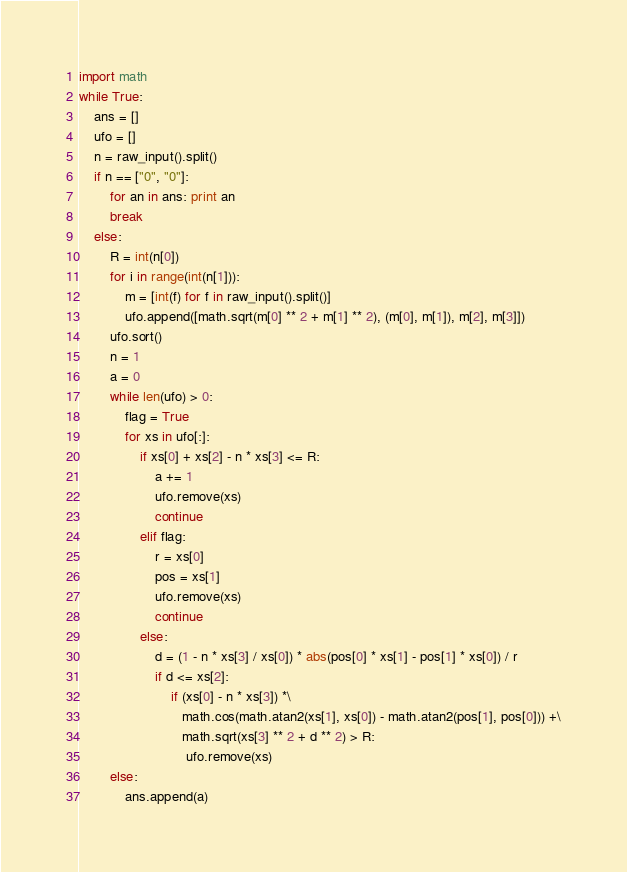Convert code to text. <code><loc_0><loc_0><loc_500><loc_500><_Python_>import math
while True:
    ans = []
    ufo = []
    n = raw_input().split()
    if n == ["0", "0"]:
        for an in ans: print an
        break
    else:
        R = int(n[0])
        for i in range(int(n[1])):
            m = [int(f) for f in raw_input().split()]
            ufo.append([math.sqrt(m[0] ** 2 + m[1] ** 2), (m[0], m[1]), m[2], m[3]])
        ufo.sort()
        n = 1
        a = 0
        while len(ufo) > 0:
            flag = True
            for xs in ufo[:]:
                if xs[0] + xs[2] - n * xs[3] <= R:
                    a += 1
                    ufo.remove(xs)
                    continue
                elif flag:
                    r = xs[0]
                    pos = xs[1]
                    ufo.remove(xs)
                    continue
                else:
                    d = (1 - n * xs[3] / xs[0]) * abs(pos[0] * xs[1] - pos[1] * xs[0]) / r
                    if d <= xs[2]:
                        if (xs[0] - n * xs[3]) *\
                           math.cos(math.atan2(xs[1], xs[0]) - math.atan2(pos[1], pos[0])) +\
                           math.sqrt(xs[3] ** 2 + d ** 2) > R:
                            ufo.remove(xs)
        else:
            ans.append(a)</code> 